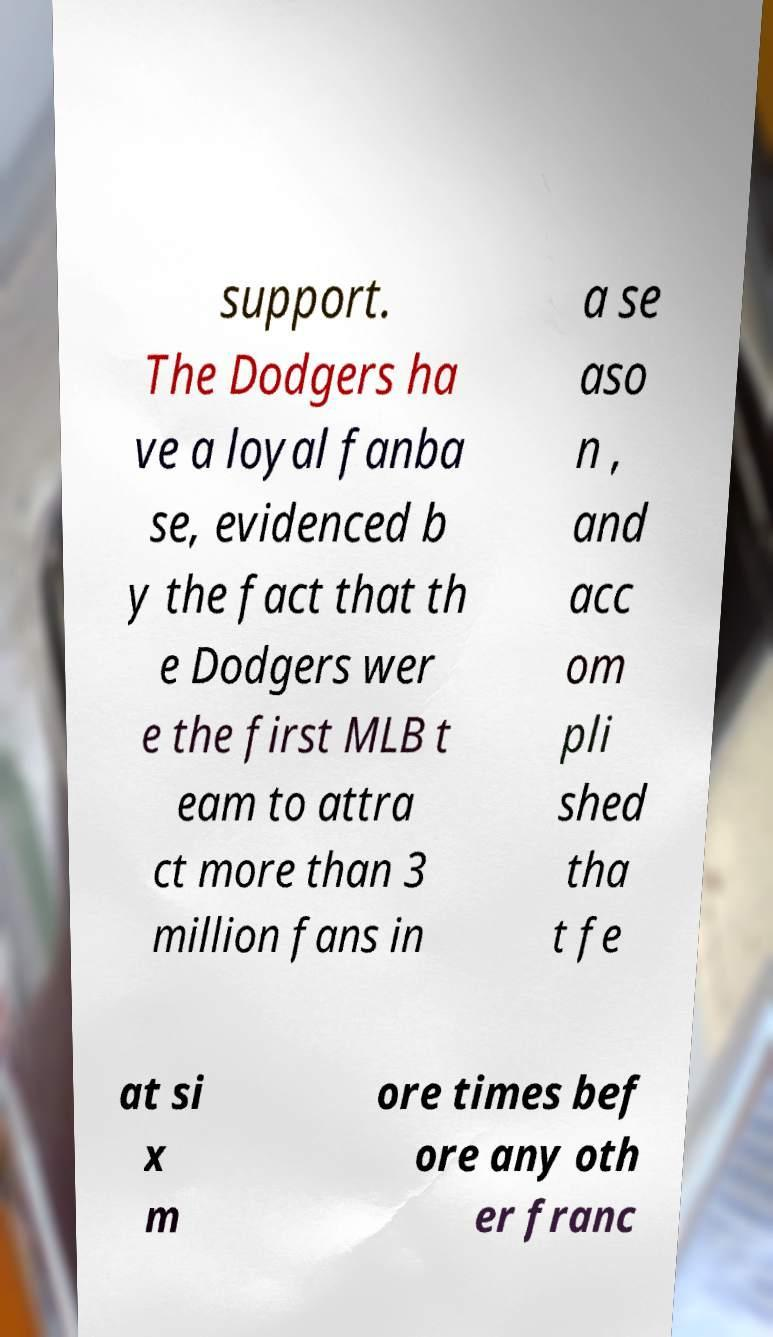There's text embedded in this image that I need extracted. Can you transcribe it verbatim? support. The Dodgers ha ve a loyal fanba se, evidenced b y the fact that th e Dodgers wer e the first MLB t eam to attra ct more than 3 million fans in a se aso n , and acc om pli shed tha t fe at si x m ore times bef ore any oth er franc 